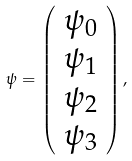Convert formula to latex. <formula><loc_0><loc_0><loc_500><loc_500>\psi = \left ( \begin{array} { c } \psi _ { 0 } \\ \psi _ { 1 } \\ \psi _ { 2 } \\ \psi _ { 3 } \end{array} \right ) ,</formula> 